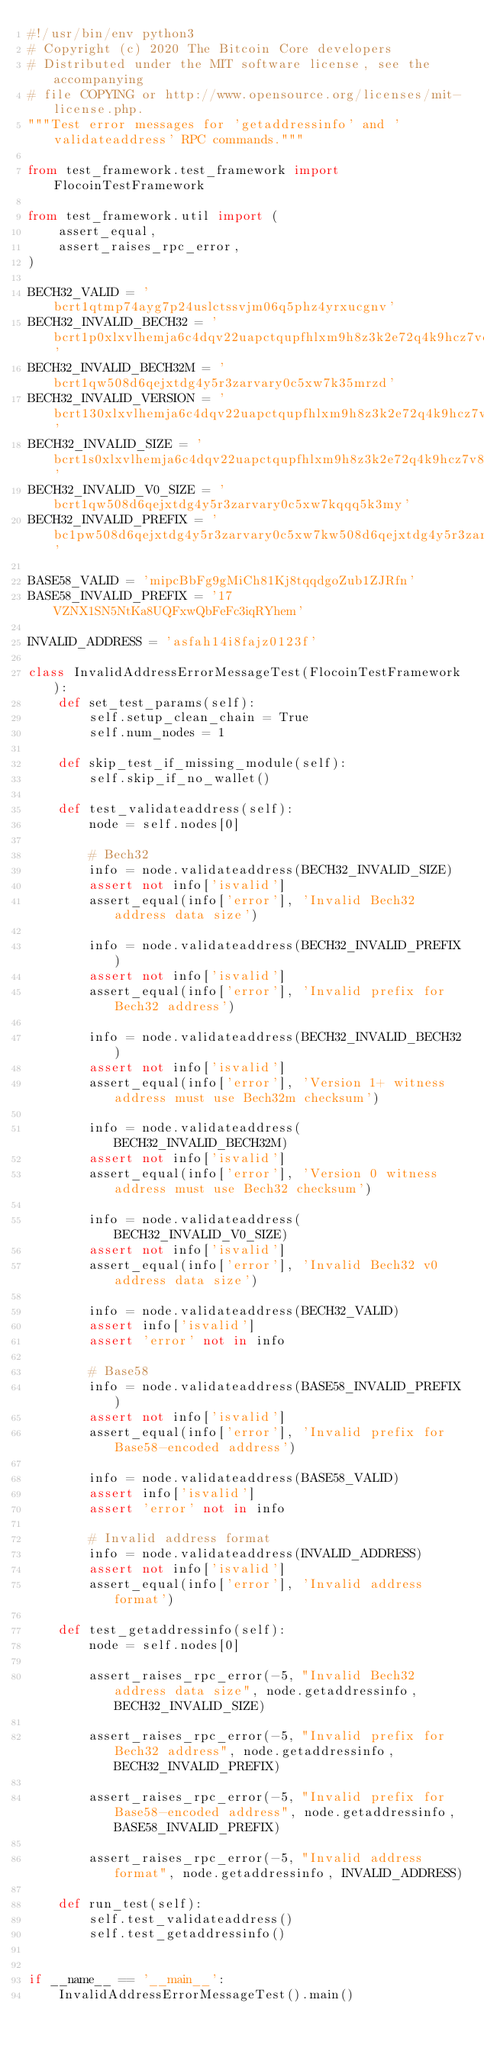<code> <loc_0><loc_0><loc_500><loc_500><_Python_>#!/usr/bin/env python3
# Copyright (c) 2020 The Bitcoin Core developers
# Distributed under the MIT software license, see the accompanying
# file COPYING or http://www.opensource.org/licenses/mit-license.php.
"""Test error messages for 'getaddressinfo' and 'validateaddress' RPC commands."""

from test_framework.test_framework import FlocoinTestFramework

from test_framework.util import (
    assert_equal,
    assert_raises_rpc_error,
)

BECH32_VALID = 'bcrt1qtmp74ayg7p24uslctssvjm06q5phz4yrxucgnv'
BECH32_INVALID_BECH32 = 'bcrt1p0xlxvlhemja6c4dqv22uapctqupfhlxm9h8z3k2e72q4k9hcz7vqdmchcc'
BECH32_INVALID_BECH32M = 'bcrt1qw508d6qejxtdg4y5r3zarvary0c5xw7k35mrzd'
BECH32_INVALID_VERSION = 'bcrt130xlxvlhemja6c4dqv22uapctqupfhlxm9h8z3k2e72q4k9hcz7vqynjegk'
BECH32_INVALID_SIZE = 'bcrt1s0xlxvlhemja6c4dqv22uapctqupfhlxm9h8z3k2e72q4k9hcz7v8n0nx0muaewav25430mtr'
BECH32_INVALID_V0_SIZE = 'bcrt1qw508d6qejxtdg4y5r3zarvary0c5xw7kqqq5k3my'
BECH32_INVALID_PREFIX = 'bc1pw508d6qejxtdg4y5r3zarvary0c5xw7kw508d6qejxtdg4y5r3zarvary0c5xw7k7grplx'

BASE58_VALID = 'mipcBbFg9gMiCh81Kj8tqqdgoZub1ZJRfn'
BASE58_INVALID_PREFIX = '17VZNX1SN5NtKa8UQFxwQbFeFc3iqRYhem'

INVALID_ADDRESS = 'asfah14i8fajz0123f'

class InvalidAddressErrorMessageTest(FlocoinTestFramework):
    def set_test_params(self):
        self.setup_clean_chain = True
        self.num_nodes = 1

    def skip_test_if_missing_module(self):
        self.skip_if_no_wallet()

    def test_validateaddress(self):
        node = self.nodes[0]

        # Bech32
        info = node.validateaddress(BECH32_INVALID_SIZE)
        assert not info['isvalid']
        assert_equal(info['error'], 'Invalid Bech32 address data size')

        info = node.validateaddress(BECH32_INVALID_PREFIX)
        assert not info['isvalid']
        assert_equal(info['error'], 'Invalid prefix for Bech32 address')

        info = node.validateaddress(BECH32_INVALID_BECH32)
        assert not info['isvalid']
        assert_equal(info['error'], 'Version 1+ witness address must use Bech32m checksum')

        info = node.validateaddress(BECH32_INVALID_BECH32M)
        assert not info['isvalid']
        assert_equal(info['error'], 'Version 0 witness address must use Bech32 checksum')

        info = node.validateaddress(BECH32_INVALID_V0_SIZE)
        assert not info['isvalid']
        assert_equal(info['error'], 'Invalid Bech32 v0 address data size')

        info = node.validateaddress(BECH32_VALID)
        assert info['isvalid']
        assert 'error' not in info

        # Base58
        info = node.validateaddress(BASE58_INVALID_PREFIX)
        assert not info['isvalid']
        assert_equal(info['error'], 'Invalid prefix for Base58-encoded address')

        info = node.validateaddress(BASE58_VALID)
        assert info['isvalid']
        assert 'error' not in info

        # Invalid address format
        info = node.validateaddress(INVALID_ADDRESS)
        assert not info['isvalid']
        assert_equal(info['error'], 'Invalid address format')

    def test_getaddressinfo(self):
        node = self.nodes[0]

        assert_raises_rpc_error(-5, "Invalid Bech32 address data size", node.getaddressinfo, BECH32_INVALID_SIZE)

        assert_raises_rpc_error(-5, "Invalid prefix for Bech32 address", node.getaddressinfo, BECH32_INVALID_PREFIX)

        assert_raises_rpc_error(-5, "Invalid prefix for Base58-encoded address", node.getaddressinfo, BASE58_INVALID_PREFIX)

        assert_raises_rpc_error(-5, "Invalid address format", node.getaddressinfo, INVALID_ADDRESS)

    def run_test(self):
        self.test_validateaddress()
        self.test_getaddressinfo()


if __name__ == '__main__':
    InvalidAddressErrorMessageTest().main()
</code> 